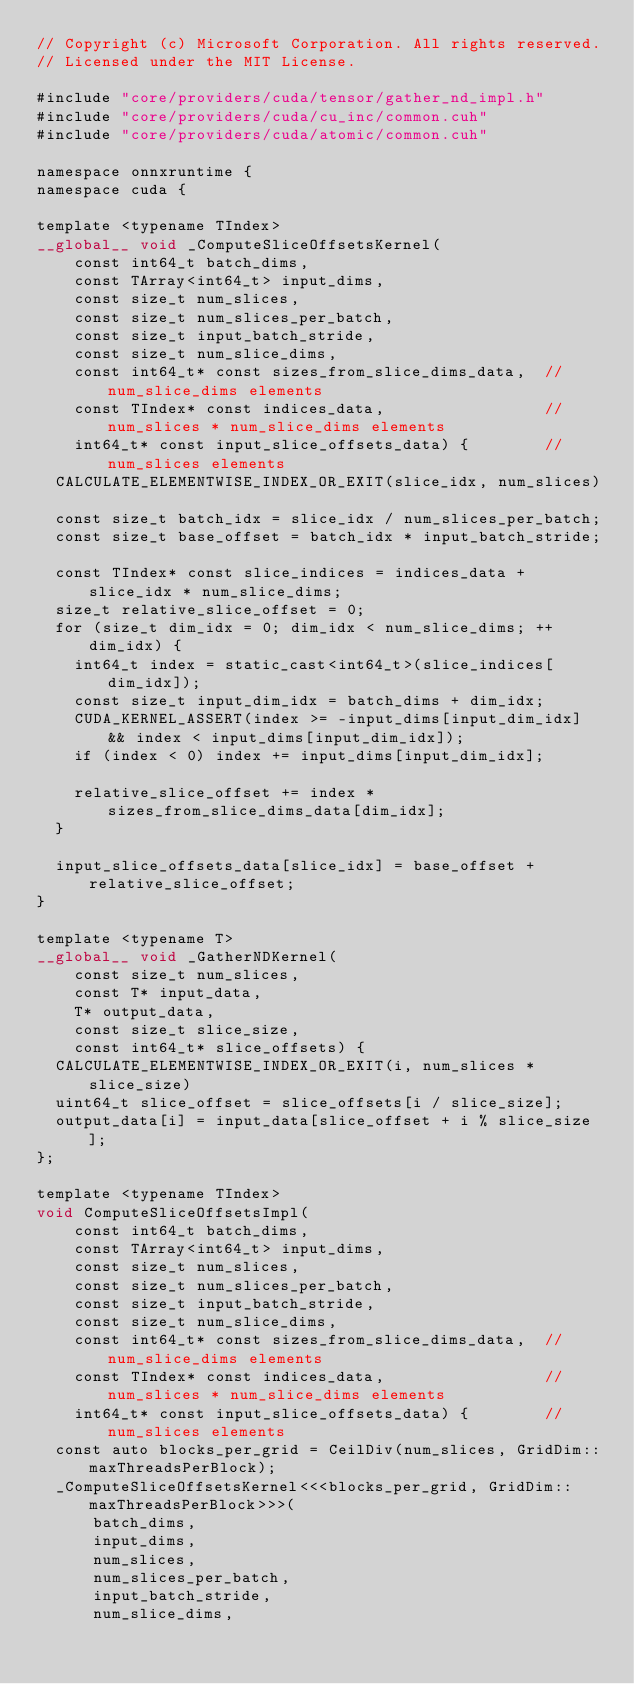Convert code to text. <code><loc_0><loc_0><loc_500><loc_500><_Cuda_>// Copyright (c) Microsoft Corporation. All rights reserved.
// Licensed under the MIT License.

#include "core/providers/cuda/tensor/gather_nd_impl.h"
#include "core/providers/cuda/cu_inc/common.cuh"
#include "core/providers/cuda/atomic/common.cuh"

namespace onnxruntime {
namespace cuda {

template <typename TIndex>
__global__ void _ComputeSliceOffsetsKernel(
    const int64_t batch_dims,
    const TArray<int64_t> input_dims,
    const size_t num_slices,
    const size_t num_slices_per_batch,
    const size_t input_batch_stride,
    const size_t num_slice_dims,
    const int64_t* const sizes_from_slice_dims_data,  // num_slice_dims elements
    const TIndex* const indices_data,                 // num_slices * num_slice_dims elements
    int64_t* const input_slice_offsets_data) {        // num_slices elements
  CALCULATE_ELEMENTWISE_INDEX_OR_EXIT(slice_idx, num_slices)

  const size_t batch_idx = slice_idx / num_slices_per_batch;
  const size_t base_offset = batch_idx * input_batch_stride;

  const TIndex* const slice_indices = indices_data + slice_idx * num_slice_dims;
  size_t relative_slice_offset = 0;
  for (size_t dim_idx = 0; dim_idx < num_slice_dims; ++dim_idx) {
    int64_t index = static_cast<int64_t>(slice_indices[dim_idx]);
    const size_t input_dim_idx = batch_dims + dim_idx;
    CUDA_KERNEL_ASSERT(index >= -input_dims[input_dim_idx] && index < input_dims[input_dim_idx]);
    if (index < 0) index += input_dims[input_dim_idx];

    relative_slice_offset += index * sizes_from_slice_dims_data[dim_idx];
  }

  input_slice_offsets_data[slice_idx] = base_offset + relative_slice_offset;
}

template <typename T>
__global__ void _GatherNDKernel(
    const size_t num_slices,
    const T* input_data,
    T* output_data,
    const size_t slice_size,
    const int64_t* slice_offsets) {
  CALCULATE_ELEMENTWISE_INDEX_OR_EXIT(i, num_slices * slice_size)
  uint64_t slice_offset = slice_offsets[i / slice_size];
  output_data[i] = input_data[slice_offset + i % slice_size];
};

template <typename TIndex>
void ComputeSliceOffsetsImpl(
    const int64_t batch_dims,
    const TArray<int64_t> input_dims,
    const size_t num_slices,
    const size_t num_slices_per_batch,
    const size_t input_batch_stride,
    const size_t num_slice_dims,
    const int64_t* const sizes_from_slice_dims_data,  // num_slice_dims elements
    const TIndex* const indices_data,                 // num_slices * num_slice_dims elements
    int64_t* const input_slice_offsets_data) {        // num_slices elements
  const auto blocks_per_grid = CeilDiv(num_slices, GridDim::maxThreadsPerBlock);
  _ComputeSliceOffsetsKernel<<<blocks_per_grid, GridDim::maxThreadsPerBlock>>>(
      batch_dims,
      input_dims,
      num_slices,
      num_slices_per_batch,
      input_batch_stride,
      num_slice_dims,</code> 